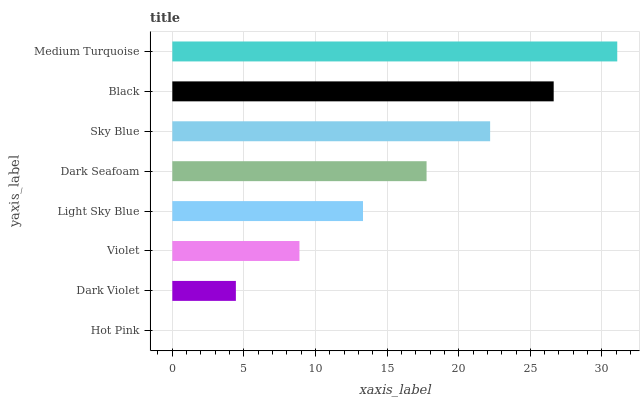Is Hot Pink the minimum?
Answer yes or no. Yes. Is Medium Turquoise the maximum?
Answer yes or no. Yes. Is Dark Violet the minimum?
Answer yes or no. No. Is Dark Violet the maximum?
Answer yes or no. No. Is Dark Violet greater than Hot Pink?
Answer yes or no. Yes. Is Hot Pink less than Dark Violet?
Answer yes or no. Yes. Is Hot Pink greater than Dark Violet?
Answer yes or no. No. Is Dark Violet less than Hot Pink?
Answer yes or no. No. Is Dark Seafoam the high median?
Answer yes or no. Yes. Is Light Sky Blue the low median?
Answer yes or no. Yes. Is Black the high median?
Answer yes or no. No. Is Black the low median?
Answer yes or no. No. 